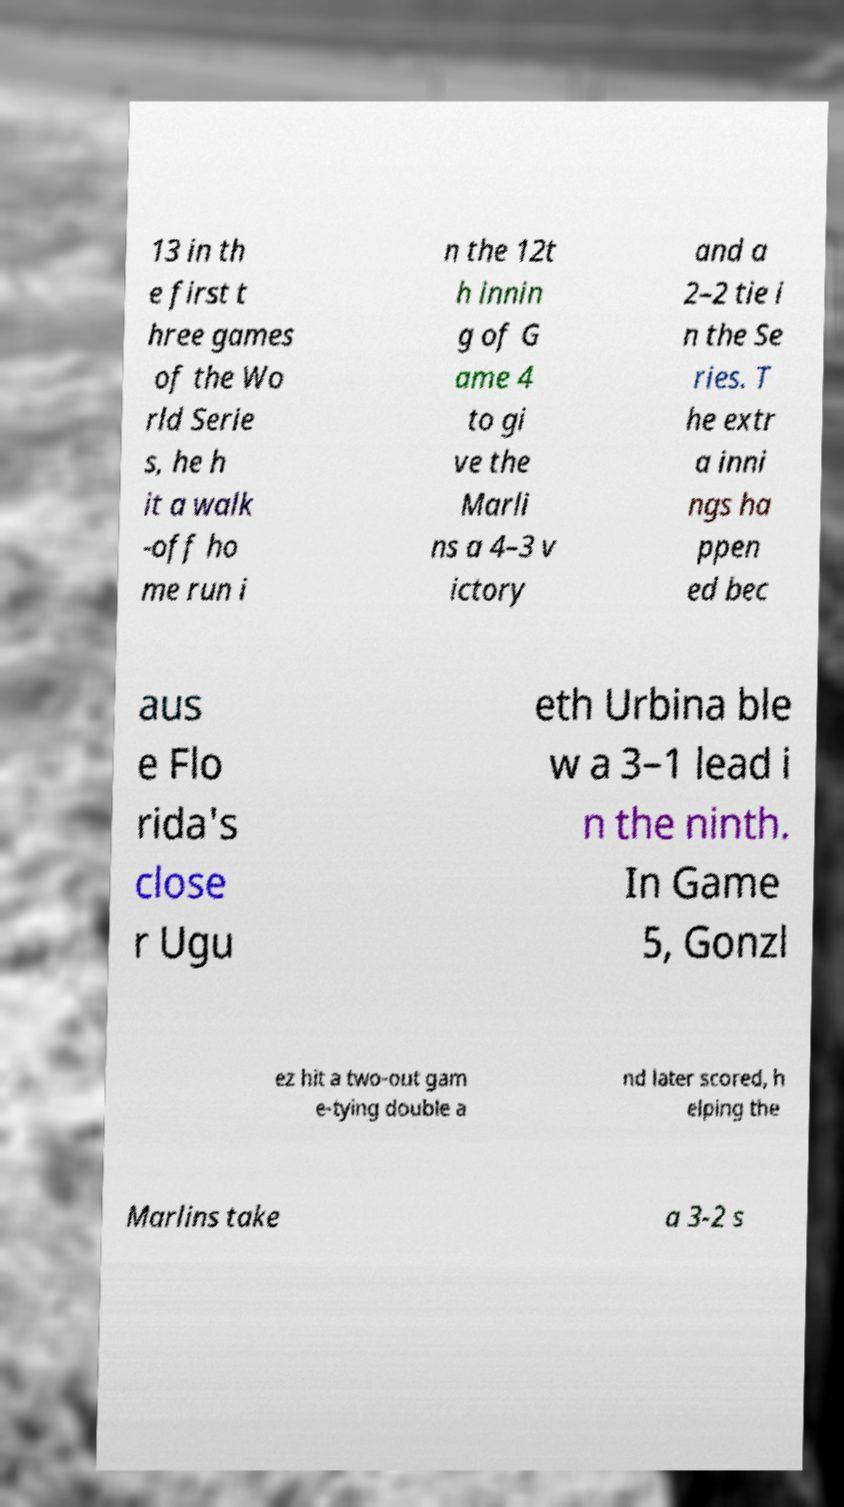Can you accurately transcribe the text from the provided image for me? 13 in th e first t hree games of the Wo rld Serie s, he h it a walk -off ho me run i n the 12t h innin g of G ame 4 to gi ve the Marli ns a 4–3 v ictory and a 2–2 tie i n the Se ries. T he extr a inni ngs ha ppen ed bec aus e Flo rida's close r Ugu eth Urbina ble w a 3–1 lead i n the ninth. In Game 5, Gonzl ez hit a two-out gam e-tying double a nd later scored, h elping the Marlins take a 3-2 s 